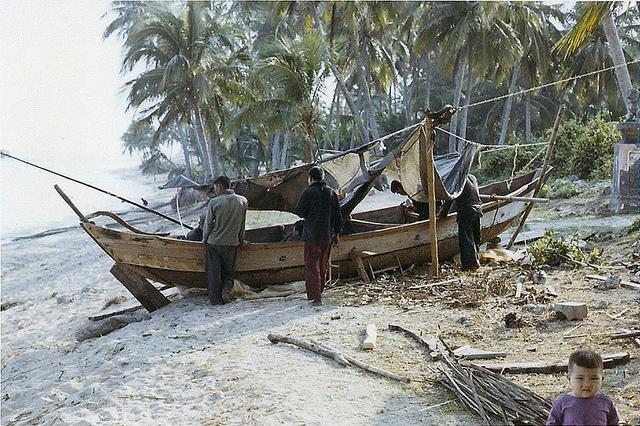What would be the most useful material for adding to the boat in this image?

Choices:
A) child
B) block
C) sticks
D) clothes sticks 